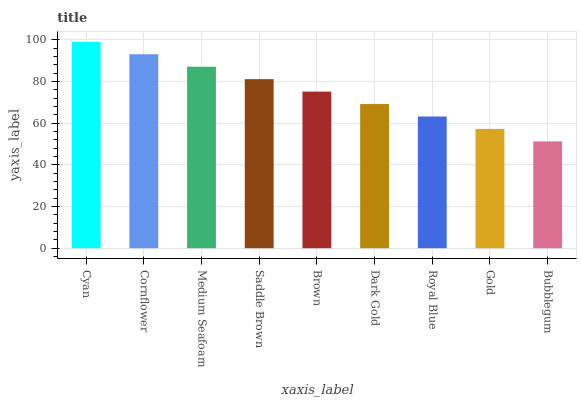Is Bubblegum the minimum?
Answer yes or no. Yes. Is Cyan the maximum?
Answer yes or no. Yes. Is Cornflower the minimum?
Answer yes or no. No. Is Cornflower the maximum?
Answer yes or no. No. Is Cyan greater than Cornflower?
Answer yes or no. Yes. Is Cornflower less than Cyan?
Answer yes or no. Yes. Is Cornflower greater than Cyan?
Answer yes or no. No. Is Cyan less than Cornflower?
Answer yes or no. No. Is Brown the high median?
Answer yes or no. Yes. Is Brown the low median?
Answer yes or no. Yes. Is Cornflower the high median?
Answer yes or no. No. Is Royal Blue the low median?
Answer yes or no. No. 